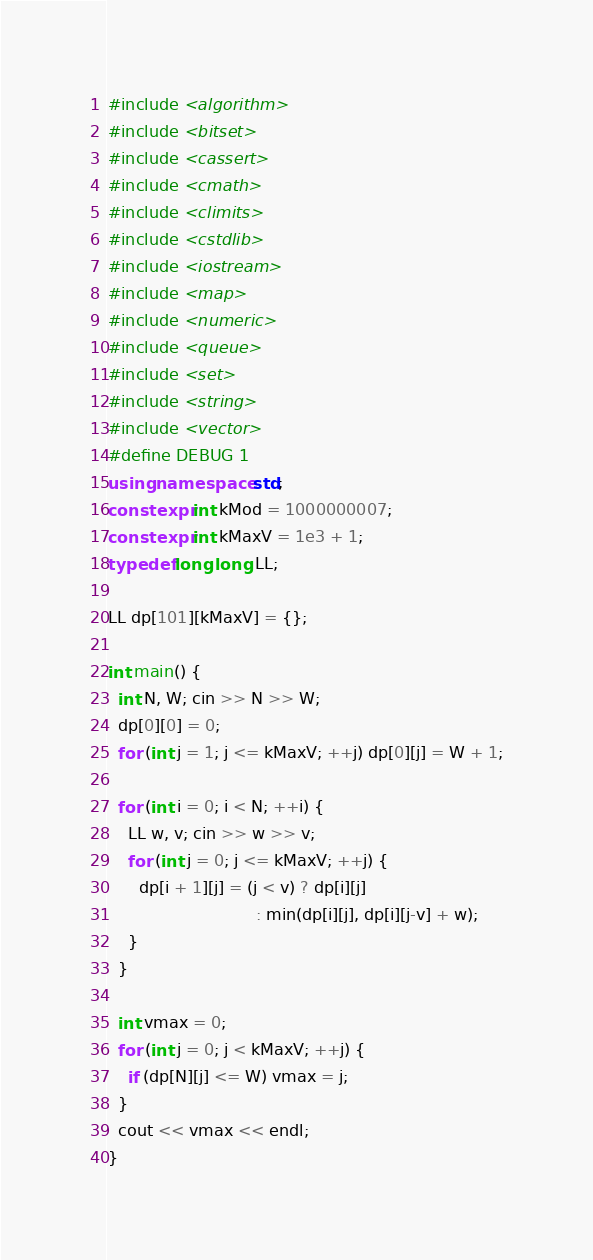Convert code to text. <code><loc_0><loc_0><loc_500><loc_500><_C++_>#include <algorithm>
#include <bitset>
#include <cassert>
#include <cmath>
#include <climits>
#include <cstdlib>
#include <iostream>
#include <map>
#include <numeric>
#include <queue>
#include <set>
#include <string>
#include <vector>
#define DEBUG 1
using namespace std;
constexpr int kMod = 1000000007;
constexpr int kMaxV = 1e3 + 1;
typedef long long LL;

LL dp[101][kMaxV] = {};

int main() {
  int N, W; cin >> N >> W;
  dp[0][0] = 0;
  for (int j = 1; j <= kMaxV; ++j) dp[0][j] = W + 1;

  for (int i = 0; i < N; ++i) {
    LL w, v; cin >> w >> v;
    for (int j = 0; j <= kMaxV; ++j) {
      dp[i + 1][j] = (j < v) ? dp[i][j]
                             : min(dp[i][j], dp[i][j-v] + w);
    }
  }

  int vmax = 0;
  for (int j = 0; j < kMaxV; ++j) {
    if (dp[N][j] <= W) vmax = j;
  }
  cout << vmax << endl;
}
</code> 